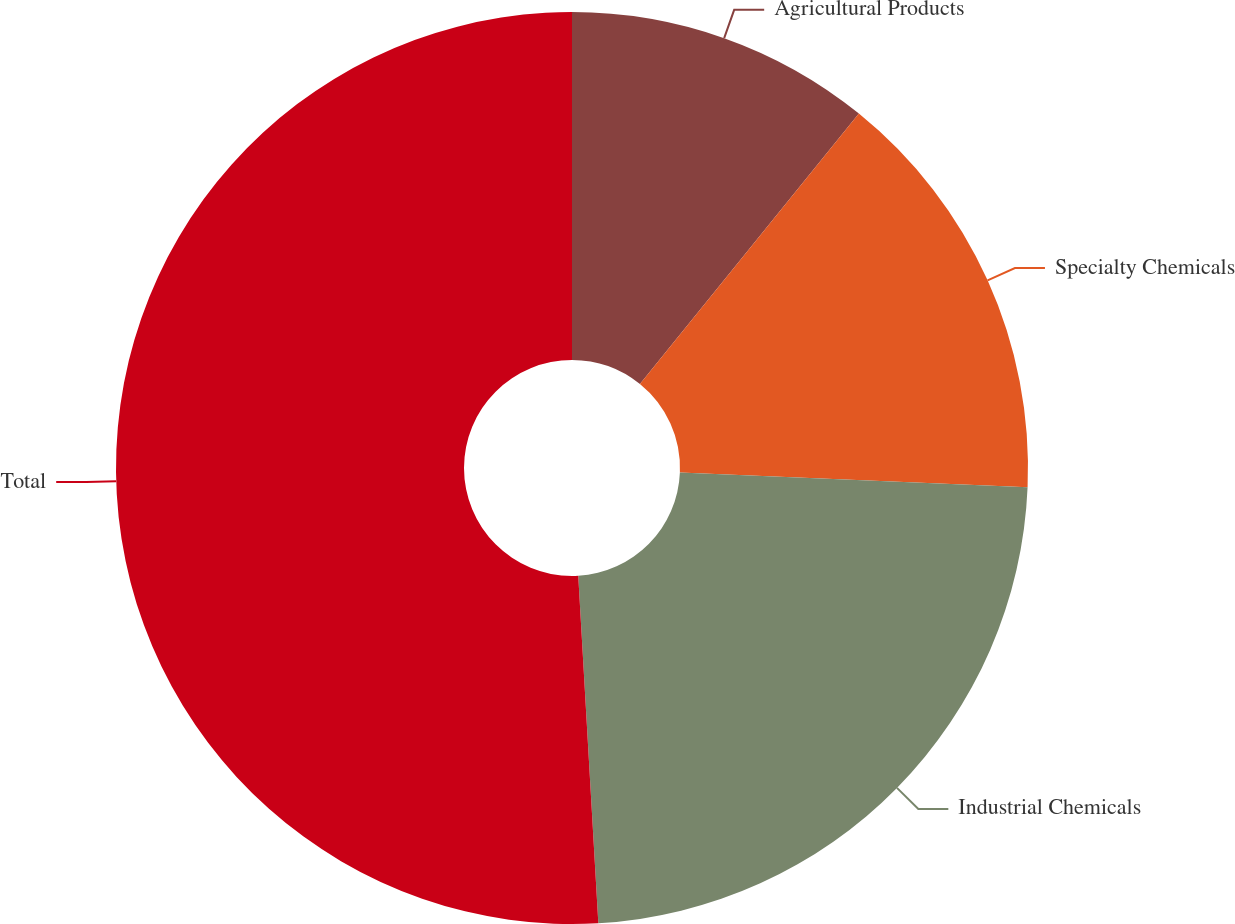Convert chart to OTSL. <chart><loc_0><loc_0><loc_500><loc_500><pie_chart><fcel>Agricultural Products<fcel>Specialty Chemicals<fcel>Industrial Chemicals<fcel>Total<nl><fcel>10.83%<fcel>14.84%<fcel>23.41%<fcel>50.92%<nl></chart> 